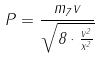<formula> <loc_0><loc_0><loc_500><loc_500>P = \frac { m _ { 7 } v } { \sqrt { 8 \cdot \frac { v ^ { 2 } } { x ^ { 2 } } } }</formula> 